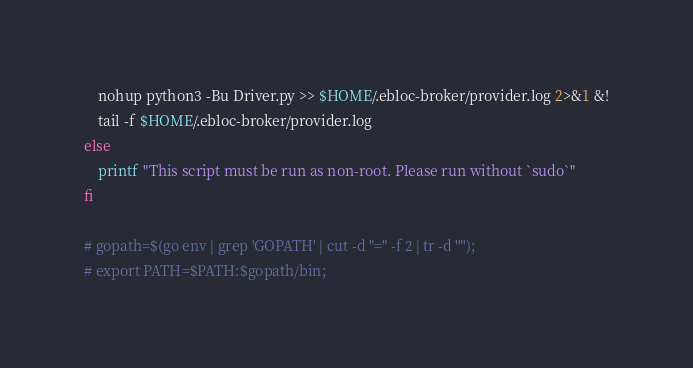<code> <loc_0><loc_0><loc_500><loc_500><_Bash_>    nohup python3 -Bu Driver.py >> $HOME/.ebloc-broker/provider.log 2>&1 &!
    tail -f $HOME/.ebloc-broker/provider.log
else
    printf "This script must be run as non-root. Please run without `sudo`"
fi

# gopath=$(go env | grep 'GOPATH' | cut -d "=" -f 2 | tr -d '"');
# export PATH=$PATH:$gopath/bin;
</code> 